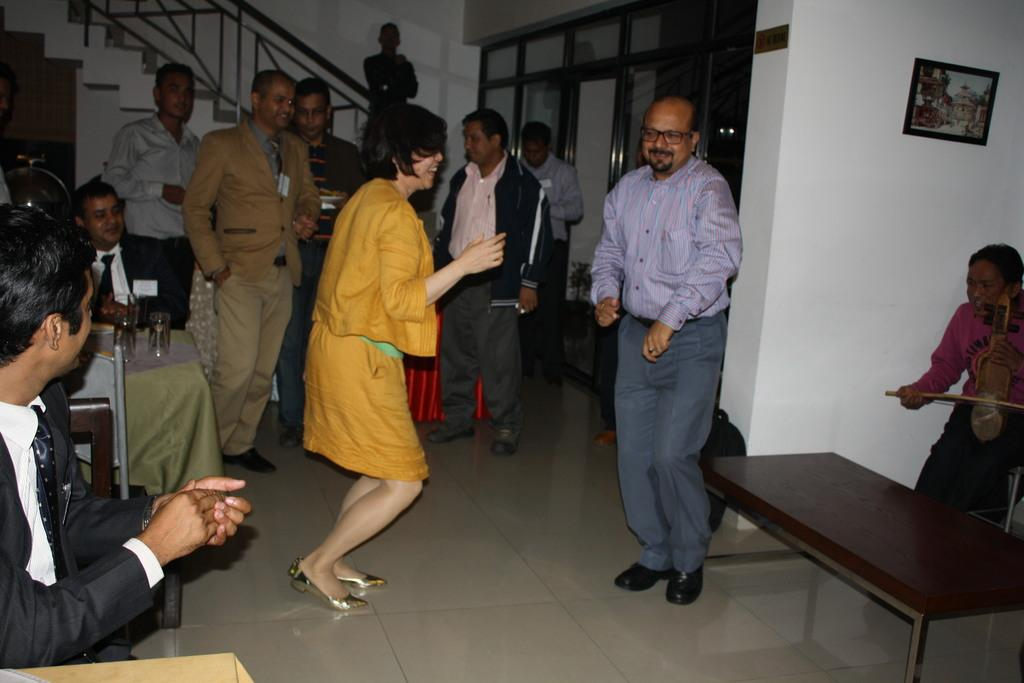What can be seen in the image? There are people standing in the image. What type of furniture is present in the image? There are tables and chairs in the image. What type of pencil can be seen on the table in the image? There is no pencil present on the table in the image. What type of school is depicted in the image? The image does not depict a school; it only shows people standing, tables, and chairs. Is there a baseball game happening in the image? There is no baseball game or any reference to baseball in the image. 